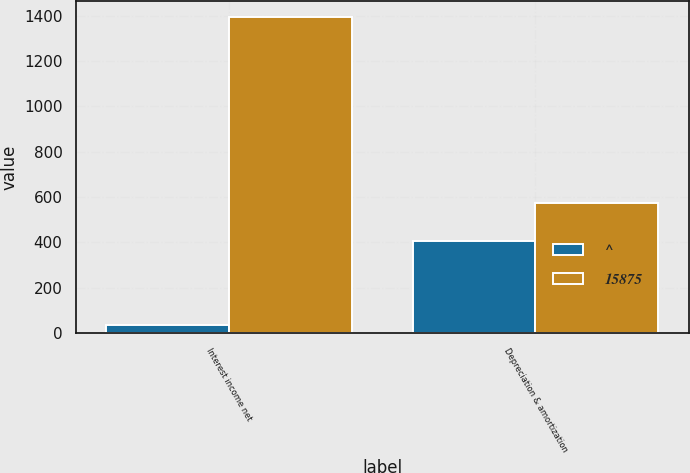Convert chart to OTSL. <chart><loc_0><loc_0><loc_500><loc_500><stacked_bar_chart><ecel><fcel>Interest income net<fcel>Depreciation & amortization<nl><fcel>^<fcel>34<fcel>404<nl><fcel>15875<fcel>1396<fcel>575<nl></chart> 